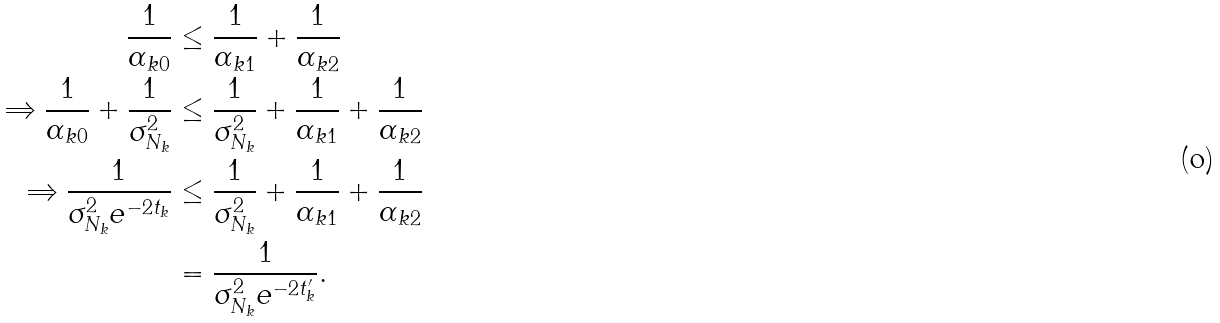Convert formula to latex. <formula><loc_0><loc_0><loc_500><loc_500>\frac { 1 } { \alpha _ { k 0 } } & \leq \frac { 1 } { \alpha _ { k 1 } } + \frac { 1 } { \alpha _ { k 2 } } \\ \Rightarrow \frac { 1 } { \alpha _ { k 0 } } + \frac { 1 } { \sigma _ { N _ { k } } ^ { 2 } } & \leq \frac { 1 } { \sigma _ { N _ { k } } ^ { 2 } } + \frac { 1 } { \alpha _ { k 1 } } + \frac { 1 } { \alpha _ { k 2 } } \\ \Rightarrow \frac { 1 } { \sigma _ { N _ { k } } ^ { 2 } e ^ { - 2 t _ { k } } } & \leq \frac { 1 } { \sigma _ { N _ { k } } ^ { 2 } } + \frac { 1 } { \alpha _ { k 1 } } + \frac { 1 } { \alpha _ { k 2 } } \\ & = \frac { 1 } { \sigma _ { N _ { k } } ^ { 2 } e ^ { - 2 t _ { k } ^ { \prime } } } .</formula> 